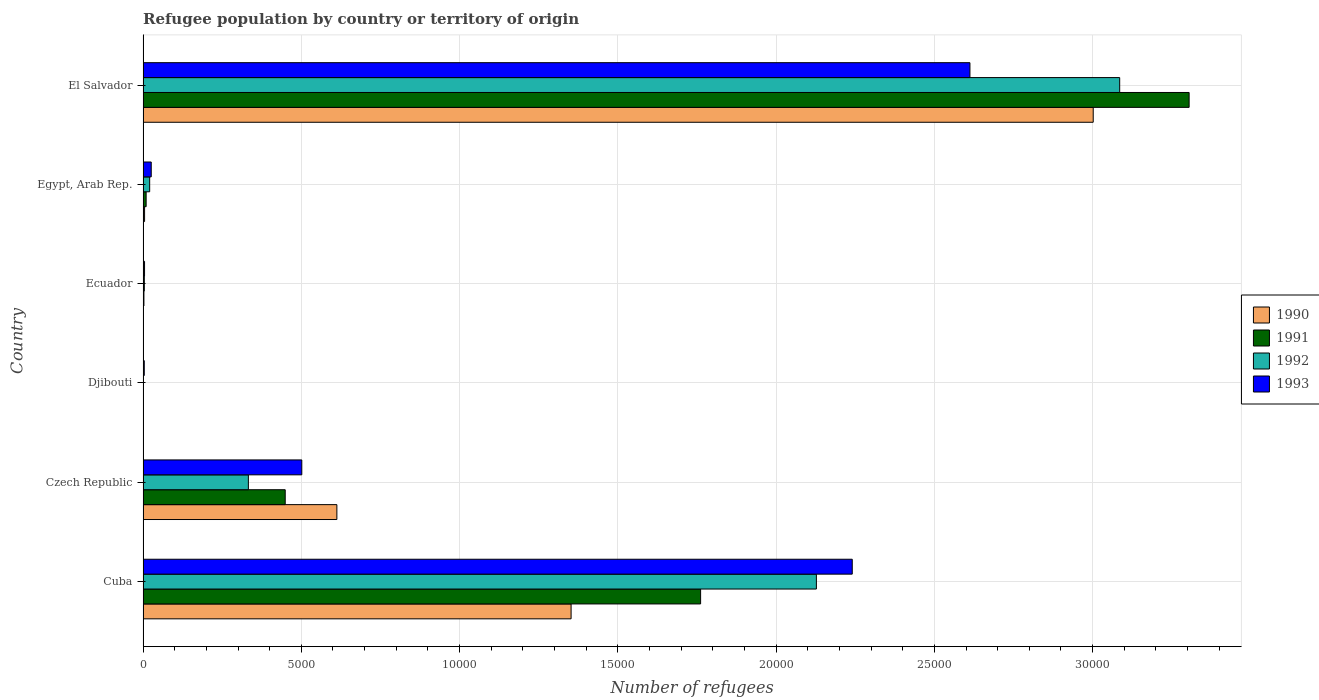How many different coloured bars are there?
Provide a short and direct response. 4. How many groups of bars are there?
Offer a terse response. 6. Are the number of bars per tick equal to the number of legend labels?
Your answer should be compact. Yes. Are the number of bars on each tick of the Y-axis equal?
Ensure brevity in your answer.  Yes. How many bars are there on the 3rd tick from the top?
Provide a succinct answer. 4. How many bars are there on the 5th tick from the bottom?
Your answer should be compact. 4. What is the label of the 4th group of bars from the top?
Your answer should be very brief. Djibouti. What is the number of refugees in 1993 in Czech Republic?
Provide a succinct answer. 5015. Across all countries, what is the maximum number of refugees in 1993?
Make the answer very short. 2.61e+04. Across all countries, what is the minimum number of refugees in 1992?
Offer a terse response. 11. In which country was the number of refugees in 1993 maximum?
Give a very brief answer. El Salvador. In which country was the number of refugees in 1993 minimum?
Provide a succinct answer. Djibouti. What is the total number of refugees in 1992 in the graph?
Your answer should be very brief. 5.57e+04. What is the difference between the number of refugees in 1990 in Cuba and that in Ecuador?
Give a very brief answer. 1.35e+04. What is the difference between the number of refugees in 1992 in El Salvador and the number of refugees in 1991 in Ecuador?
Offer a very short reply. 3.08e+04. What is the average number of refugees in 1991 per country?
Provide a succinct answer. 9214.83. What is the difference between the number of refugees in 1992 and number of refugees in 1993 in Ecuador?
Provide a succinct answer. -7. In how many countries, is the number of refugees in 1992 greater than 10000 ?
Offer a very short reply. 2. What is the ratio of the number of refugees in 1992 in Czech Republic to that in Djibouti?
Offer a terse response. 302.45. Is the number of refugees in 1991 in Djibouti less than that in El Salvador?
Ensure brevity in your answer.  Yes. Is the difference between the number of refugees in 1992 in Djibouti and Ecuador greater than the difference between the number of refugees in 1993 in Djibouti and Ecuador?
Offer a terse response. No. What is the difference between the highest and the second highest number of refugees in 1990?
Your answer should be compact. 1.65e+04. What is the difference between the highest and the lowest number of refugees in 1991?
Provide a short and direct response. 3.30e+04. Is the sum of the number of refugees in 1991 in Cuba and El Salvador greater than the maximum number of refugees in 1990 across all countries?
Your answer should be compact. Yes. What does the 1st bar from the bottom in Djibouti represents?
Offer a very short reply. 1990. Is it the case that in every country, the sum of the number of refugees in 1993 and number of refugees in 1990 is greater than the number of refugees in 1992?
Give a very brief answer. Yes. How many bars are there?
Offer a terse response. 24. Does the graph contain any zero values?
Provide a succinct answer. No. How many legend labels are there?
Your answer should be very brief. 4. How are the legend labels stacked?
Provide a succinct answer. Vertical. What is the title of the graph?
Provide a succinct answer. Refugee population by country or territory of origin. What is the label or title of the X-axis?
Your answer should be very brief. Number of refugees. What is the Number of refugees in 1990 in Cuba?
Offer a very short reply. 1.35e+04. What is the Number of refugees in 1991 in Cuba?
Make the answer very short. 1.76e+04. What is the Number of refugees of 1992 in Cuba?
Provide a short and direct response. 2.13e+04. What is the Number of refugees in 1993 in Cuba?
Your answer should be very brief. 2.24e+04. What is the Number of refugees of 1990 in Czech Republic?
Provide a succinct answer. 6123. What is the Number of refugees in 1991 in Czech Republic?
Provide a short and direct response. 4491. What is the Number of refugees in 1992 in Czech Republic?
Keep it short and to the point. 3327. What is the Number of refugees of 1993 in Czech Republic?
Keep it short and to the point. 5015. What is the Number of refugees of 1992 in Djibouti?
Your response must be concise. 11. What is the Number of refugees in 1990 in Ecuador?
Provide a short and direct response. 3. What is the Number of refugees of 1992 in Ecuador?
Ensure brevity in your answer.  40. What is the Number of refugees in 1990 in Egypt, Arab Rep.?
Your response must be concise. 48. What is the Number of refugees in 1991 in Egypt, Arab Rep.?
Your answer should be very brief. 97. What is the Number of refugees of 1992 in Egypt, Arab Rep.?
Offer a very short reply. 209. What is the Number of refugees in 1993 in Egypt, Arab Rep.?
Keep it short and to the point. 258. What is the Number of refugees of 1990 in El Salvador?
Ensure brevity in your answer.  3.00e+04. What is the Number of refugees in 1991 in El Salvador?
Provide a short and direct response. 3.30e+04. What is the Number of refugees of 1992 in El Salvador?
Provide a short and direct response. 3.09e+04. What is the Number of refugees of 1993 in El Salvador?
Keep it short and to the point. 2.61e+04. Across all countries, what is the maximum Number of refugees in 1990?
Your response must be concise. 3.00e+04. Across all countries, what is the maximum Number of refugees of 1991?
Ensure brevity in your answer.  3.30e+04. Across all countries, what is the maximum Number of refugees in 1992?
Make the answer very short. 3.09e+04. Across all countries, what is the maximum Number of refugees of 1993?
Make the answer very short. 2.61e+04. Across all countries, what is the minimum Number of refugees in 1990?
Make the answer very short. 3. Across all countries, what is the minimum Number of refugees of 1992?
Offer a very short reply. 11. What is the total Number of refugees of 1990 in the graph?
Offer a terse response. 4.97e+04. What is the total Number of refugees of 1991 in the graph?
Keep it short and to the point. 5.53e+04. What is the total Number of refugees in 1992 in the graph?
Your answer should be very brief. 5.57e+04. What is the total Number of refugees of 1993 in the graph?
Offer a terse response. 5.39e+04. What is the difference between the Number of refugees in 1990 in Cuba and that in Czech Republic?
Provide a short and direct response. 7400. What is the difference between the Number of refugees of 1991 in Cuba and that in Czech Republic?
Your response must be concise. 1.31e+04. What is the difference between the Number of refugees in 1992 in Cuba and that in Czech Republic?
Offer a terse response. 1.79e+04. What is the difference between the Number of refugees in 1993 in Cuba and that in Czech Republic?
Your answer should be compact. 1.74e+04. What is the difference between the Number of refugees of 1990 in Cuba and that in Djibouti?
Make the answer very short. 1.35e+04. What is the difference between the Number of refugees in 1991 in Cuba and that in Djibouti?
Keep it short and to the point. 1.76e+04. What is the difference between the Number of refugees of 1992 in Cuba and that in Djibouti?
Offer a very short reply. 2.13e+04. What is the difference between the Number of refugees of 1993 in Cuba and that in Djibouti?
Your answer should be very brief. 2.24e+04. What is the difference between the Number of refugees of 1990 in Cuba and that in Ecuador?
Make the answer very short. 1.35e+04. What is the difference between the Number of refugees in 1991 in Cuba and that in Ecuador?
Your answer should be very brief. 1.76e+04. What is the difference between the Number of refugees in 1992 in Cuba and that in Ecuador?
Give a very brief answer. 2.12e+04. What is the difference between the Number of refugees of 1993 in Cuba and that in Ecuador?
Keep it short and to the point. 2.24e+04. What is the difference between the Number of refugees of 1990 in Cuba and that in Egypt, Arab Rep.?
Your answer should be very brief. 1.35e+04. What is the difference between the Number of refugees in 1991 in Cuba and that in Egypt, Arab Rep.?
Give a very brief answer. 1.75e+04. What is the difference between the Number of refugees of 1992 in Cuba and that in Egypt, Arab Rep.?
Make the answer very short. 2.11e+04. What is the difference between the Number of refugees in 1993 in Cuba and that in Egypt, Arab Rep.?
Provide a short and direct response. 2.21e+04. What is the difference between the Number of refugees in 1990 in Cuba and that in El Salvador?
Your response must be concise. -1.65e+04. What is the difference between the Number of refugees of 1991 in Cuba and that in El Salvador?
Provide a short and direct response. -1.54e+04. What is the difference between the Number of refugees of 1992 in Cuba and that in El Salvador?
Offer a terse response. -9582. What is the difference between the Number of refugees in 1993 in Cuba and that in El Salvador?
Offer a very short reply. -3718. What is the difference between the Number of refugees in 1990 in Czech Republic and that in Djibouti?
Your response must be concise. 6118. What is the difference between the Number of refugees of 1991 in Czech Republic and that in Djibouti?
Offer a very short reply. 4481. What is the difference between the Number of refugees of 1992 in Czech Republic and that in Djibouti?
Offer a very short reply. 3316. What is the difference between the Number of refugees of 1993 in Czech Republic and that in Djibouti?
Ensure brevity in your answer.  4977. What is the difference between the Number of refugees in 1990 in Czech Republic and that in Ecuador?
Offer a terse response. 6120. What is the difference between the Number of refugees of 1991 in Czech Republic and that in Ecuador?
Make the answer very short. 4464. What is the difference between the Number of refugees of 1992 in Czech Republic and that in Ecuador?
Your answer should be compact. 3287. What is the difference between the Number of refugees of 1993 in Czech Republic and that in Ecuador?
Give a very brief answer. 4968. What is the difference between the Number of refugees in 1990 in Czech Republic and that in Egypt, Arab Rep.?
Keep it short and to the point. 6075. What is the difference between the Number of refugees in 1991 in Czech Republic and that in Egypt, Arab Rep.?
Give a very brief answer. 4394. What is the difference between the Number of refugees of 1992 in Czech Republic and that in Egypt, Arab Rep.?
Give a very brief answer. 3118. What is the difference between the Number of refugees of 1993 in Czech Republic and that in Egypt, Arab Rep.?
Offer a terse response. 4757. What is the difference between the Number of refugees in 1990 in Czech Republic and that in El Salvador?
Your answer should be very brief. -2.39e+04. What is the difference between the Number of refugees in 1991 in Czech Republic and that in El Salvador?
Provide a succinct answer. -2.86e+04. What is the difference between the Number of refugees in 1992 in Czech Republic and that in El Salvador?
Your answer should be compact. -2.75e+04. What is the difference between the Number of refugees in 1993 in Czech Republic and that in El Salvador?
Offer a very short reply. -2.11e+04. What is the difference between the Number of refugees in 1993 in Djibouti and that in Ecuador?
Your response must be concise. -9. What is the difference between the Number of refugees of 1990 in Djibouti and that in Egypt, Arab Rep.?
Provide a short and direct response. -43. What is the difference between the Number of refugees of 1991 in Djibouti and that in Egypt, Arab Rep.?
Provide a succinct answer. -87. What is the difference between the Number of refugees in 1992 in Djibouti and that in Egypt, Arab Rep.?
Give a very brief answer. -198. What is the difference between the Number of refugees in 1993 in Djibouti and that in Egypt, Arab Rep.?
Offer a terse response. -220. What is the difference between the Number of refugees in 1990 in Djibouti and that in El Salvador?
Keep it short and to the point. -3.00e+04. What is the difference between the Number of refugees of 1991 in Djibouti and that in El Salvador?
Offer a very short reply. -3.30e+04. What is the difference between the Number of refugees in 1992 in Djibouti and that in El Salvador?
Ensure brevity in your answer.  -3.08e+04. What is the difference between the Number of refugees in 1993 in Djibouti and that in El Salvador?
Give a very brief answer. -2.61e+04. What is the difference between the Number of refugees of 1990 in Ecuador and that in Egypt, Arab Rep.?
Make the answer very short. -45. What is the difference between the Number of refugees in 1991 in Ecuador and that in Egypt, Arab Rep.?
Keep it short and to the point. -70. What is the difference between the Number of refugees in 1992 in Ecuador and that in Egypt, Arab Rep.?
Your answer should be compact. -169. What is the difference between the Number of refugees of 1993 in Ecuador and that in Egypt, Arab Rep.?
Your answer should be compact. -211. What is the difference between the Number of refugees in 1990 in Ecuador and that in El Salvador?
Give a very brief answer. -3.00e+04. What is the difference between the Number of refugees of 1991 in Ecuador and that in El Salvador?
Provide a succinct answer. -3.30e+04. What is the difference between the Number of refugees in 1992 in Ecuador and that in El Salvador?
Provide a succinct answer. -3.08e+04. What is the difference between the Number of refugees in 1993 in Ecuador and that in El Salvador?
Keep it short and to the point. -2.61e+04. What is the difference between the Number of refugees of 1990 in Egypt, Arab Rep. and that in El Salvador?
Provide a short and direct response. -3.00e+04. What is the difference between the Number of refugees of 1991 in Egypt, Arab Rep. and that in El Salvador?
Offer a very short reply. -3.30e+04. What is the difference between the Number of refugees in 1992 in Egypt, Arab Rep. and that in El Salvador?
Make the answer very short. -3.06e+04. What is the difference between the Number of refugees in 1993 in Egypt, Arab Rep. and that in El Salvador?
Your answer should be compact. -2.59e+04. What is the difference between the Number of refugees of 1990 in Cuba and the Number of refugees of 1991 in Czech Republic?
Give a very brief answer. 9032. What is the difference between the Number of refugees of 1990 in Cuba and the Number of refugees of 1992 in Czech Republic?
Offer a very short reply. 1.02e+04. What is the difference between the Number of refugees in 1990 in Cuba and the Number of refugees in 1993 in Czech Republic?
Make the answer very short. 8508. What is the difference between the Number of refugees of 1991 in Cuba and the Number of refugees of 1992 in Czech Republic?
Offer a terse response. 1.43e+04. What is the difference between the Number of refugees of 1991 in Cuba and the Number of refugees of 1993 in Czech Republic?
Your response must be concise. 1.26e+04. What is the difference between the Number of refugees of 1992 in Cuba and the Number of refugees of 1993 in Czech Republic?
Your answer should be very brief. 1.63e+04. What is the difference between the Number of refugees of 1990 in Cuba and the Number of refugees of 1991 in Djibouti?
Your answer should be compact. 1.35e+04. What is the difference between the Number of refugees of 1990 in Cuba and the Number of refugees of 1992 in Djibouti?
Your answer should be very brief. 1.35e+04. What is the difference between the Number of refugees in 1990 in Cuba and the Number of refugees in 1993 in Djibouti?
Your answer should be compact. 1.35e+04. What is the difference between the Number of refugees in 1991 in Cuba and the Number of refugees in 1992 in Djibouti?
Make the answer very short. 1.76e+04. What is the difference between the Number of refugees in 1991 in Cuba and the Number of refugees in 1993 in Djibouti?
Offer a terse response. 1.76e+04. What is the difference between the Number of refugees in 1992 in Cuba and the Number of refugees in 1993 in Djibouti?
Give a very brief answer. 2.12e+04. What is the difference between the Number of refugees in 1990 in Cuba and the Number of refugees in 1991 in Ecuador?
Provide a succinct answer. 1.35e+04. What is the difference between the Number of refugees in 1990 in Cuba and the Number of refugees in 1992 in Ecuador?
Your answer should be compact. 1.35e+04. What is the difference between the Number of refugees of 1990 in Cuba and the Number of refugees of 1993 in Ecuador?
Provide a succinct answer. 1.35e+04. What is the difference between the Number of refugees of 1991 in Cuba and the Number of refugees of 1992 in Ecuador?
Make the answer very short. 1.76e+04. What is the difference between the Number of refugees in 1991 in Cuba and the Number of refugees in 1993 in Ecuador?
Your answer should be compact. 1.76e+04. What is the difference between the Number of refugees of 1992 in Cuba and the Number of refugees of 1993 in Ecuador?
Your response must be concise. 2.12e+04. What is the difference between the Number of refugees in 1990 in Cuba and the Number of refugees in 1991 in Egypt, Arab Rep.?
Provide a succinct answer. 1.34e+04. What is the difference between the Number of refugees of 1990 in Cuba and the Number of refugees of 1992 in Egypt, Arab Rep.?
Provide a succinct answer. 1.33e+04. What is the difference between the Number of refugees in 1990 in Cuba and the Number of refugees in 1993 in Egypt, Arab Rep.?
Your answer should be compact. 1.33e+04. What is the difference between the Number of refugees in 1991 in Cuba and the Number of refugees in 1992 in Egypt, Arab Rep.?
Ensure brevity in your answer.  1.74e+04. What is the difference between the Number of refugees in 1991 in Cuba and the Number of refugees in 1993 in Egypt, Arab Rep.?
Keep it short and to the point. 1.74e+04. What is the difference between the Number of refugees of 1992 in Cuba and the Number of refugees of 1993 in Egypt, Arab Rep.?
Keep it short and to the point. 2.10e+04. What is the difference between the Number of refugees of 1990 in Cuba and the Number of refugees of 1991 in El Salvador?
Your response must be concise. -1.95e+04. What is the difference between the Number of refugees of 1990 in Cuba and the Number of refugees of 1992 in El Salvador?
Keep it short and to the point. -1.73e+04. What is the difference between the Number of refugees in 1990 in Cuba and the Number of refugees in 1993 in El Salvador?
Offer a very short reply. -1.26e+04. What is the difference between the Number of refugees of 1991 in Cuba and the Number of refugees of 1992 in El Salvador?
Ensure brevity in your answer.  -1.32e+04. What is the difference between the Number of refugees in 1991 in Cuba and the Number of refugees in 1993 in El Salvador?
Ensure brevity in your answer.  -8509. What is the difference between the Number of refugees of 1992 in Cuba and the Number of refugees of 1993 in El Salvador?
Offer a very short reply. -4851. What is the difference between the Number of refugees of 1990 in Czech Republic and the Number of refugees of 1991 in Djibouti?
Your answer should be compact. 6113. What is the difference between the Number of refugees of 1990 in Czech Republic and the Number of refugees of 1992 in Djibouti?
Make the answer very short. 6112. What is the difference between the Number of refugees of 1990 in Czech Republic and the Number of refugees of 1993 in Djibouti?
Your answer should be very brief. 6085. What is the difference between the Number of refugees in 1991 in Czech Republic and the Number of refugees in 1992 in Djibouti?
Make the answer very short. 4480. What is the difference between the Number of refugees in 1991 in Czech Republic and the Number of refugees in 1993 in Djibouti?
Make the answer very short. 4453. What is the difference between the Number of refugees in 1992 in Czech Republic and the Number of refugees in 1993 in Djibouti?
Give a very brief answer. 3289. What is the difference between the Number of refugees in 1990 in Czech Republic and the Number of refugees in 1991 in Ecuador?
Provide a short and direct response. 6096. What is the difference between the Number of refugees in 1990 in Czech Republic and the Number of refugees in 1992 in Ecuador?
Make the answer very short. 6083. What is the difference between the Number of refugees in 1990 in Czech Republic and the Number of refugees in 1993 in Ecuador?
Provide a short and direct response. 6076. What is the difference between the Number of refugees of 1991 in Czech Republic and the Number of refugees of 1992 in Ecuador?
Your answer should be compact. 4451. What is the difference between the Number of refugees in 1991 in Czech Republic and the Number of refugees in 1993 in Ecuador?
Offer a very short reply. 4444. What is the difference between the Number of refugees of 1992 in Czech Republic and the Number of refugees of 1993 in Ecuador?
Offer a terse response. 3280. What is the difference between the Number of refugees of 1990 in Czech Republic and the Number of refugees of 1991 in Egypt, Arab Rep.?
Ensure brevity in your answer.  6026. What is the difference between the Number of refugees of 1990 in Czech Republic and the Number of refugees of 1992 in Egypt, Arab Rep.?
Your response must be concise. 5914. What is the difference between the Number of refugees of 1990 in Czech Republic and the Number of refugees of 1993 in Egypt, Arab Rep.?
Your answer should be very brief. 5865. What is the difference between the Number of refugees of 1991 in Czech Republic and the Number of refugees of 1992 in Egypt, Arab Rep.?
Your answer should be very brief. 4282. What is the difference between the Number of refugees of 1991 in Czech Republic and the Number of refugees of 1993 in Egypt, Arab Rep.?
Ensure brevity in your answer.  4233. What is the difference between the Number of refugees of 1992 in Czech Republic and the Number of refugees of 1993 in Egypt, Arab Rep.?
Offer a very short reply. 3069. What is the difference between the Number of refugees in 1990 in Czech Republic and the Number of refugees in 1991 in El Salvador?
Make the answer very short. -2.69e+04. What is the difference between the Number of refugees of 1990 in Czech Republic and the Number of refugees of 1992 in El Salvador?
Your response must be concise. -2.47e+04. What is the difference between the Number of refugees in 1990 in Czech Republic and the Number of refugees in 1993 in El Salvador?
Keep it short and to the point. -2.00e+04. What is the difference between the Number of refugees in 1991 in Czech Republic and the Number of refugees in 1992 in El Salvador?
Your response must be concise. -2.64e+04. What is the difference between the Number of refugees of 1991 in Czech Republic and the Number of refugees of 1993 in El Salvador?
Your answer should be compact. -2.16e+04. What is the difference between the Number of refugees in 1992 in Czech Republic and the Number of refugees in 1993 in El Salvador?
Provide a short and direct response. -2.28e+04. What is the difference between the Number of refugees of 1990 in Djibouti and the Number of refugees of 1992 in Ecuador?
Offer a very short reply. -35. What is the difference between the Number of refugees in 1990 in Djibouti and the Number of refugees in 1993 in Ecuador?
Provide a short and direct response. -42. What is the difference between the Number of refugees in 1991 in Djibouti and the Number of refugees in 1993 in Ecuador?
Provide a short and direct response. -37. What is the difference between the Number of refugees of 1992 in Djibouti and the Number of refugees of 1993 in Ecuador?
Ensure brevity in your answer.  -36. What is the difference between the Number of refugees in 1990 in Djibouti and the Number of refugees in 1991 in Egypt, Arab Rep.?
Provide a succinct answer. -92. What is the difference between the Number of refugees in 1990 in Djibouti and the Number of refugees in 1992 in Egypt, Arab Rep.?
Your answer should be compact. -204. What is the difference between the Number of refugees in 1990 in Djibouti and the Number of refugees in 1993 in Egypt, Arab Rep.?
Offer a terse response. -253. What is the difference between the Number of refugees of 1991 in Djibouti and the Number of refugees of 1992 in Egypt, Arab Rep.?
Provide a short and direct response. -199. What is the difference between the Number of refugees of 1991 in Djibouti and the Number of refugees of 1993 in Egypt, Arab Rep.?
Provide a short and direct response. -248. What is the difference between the Number of refugees in 1992 in Djibouti and the Number of refugees in 1993 in Egypt, Arab Rep.?
Your answer should be compact. -247. What is the difference between the Number of refugees in 1990 in Djibouti and the Number of refugees in 1991 in El Salvador?
Provide a succinct answer. -3.30e+04. What is the difference between the Number of refugees in 1990 in Djibouti and the Number of refugees in 1992 in El Salvador?
Your answer should be very brief. -3.08e+04. What is the difference between the Number of refugees of 1990 in Djibouti and the Number of refugees of 1993 in El Salvador?
Ensure brevity in your answer.  -2.61e+04. What is the difference between the Number of refugees in 1991 in Djibouti and the Number of refugees in 1992 in El Salvador?
Give a very brief answer. -3.08e+04. What is the difference between the Number of refugees of 1991 in Djibouti and the Number of refugees of 1993 in El Salvador?
Ensure brevity in your answer.  -2.61e+04. What is the difference between the Number of refugees in 1992 in Djibouti and the Number of refugees in 1993 in El Salvador?
Give a very brief answer. -2.61e+04. What is the difference between the Number of refugees in 1990 in Ecuador and the Number of refugees in 1991 in Egypt, Arab Rep.?
Your answer should be compact. -94. What is the difference between the Number of refugees of 1990 in Ecuador and the Number of refugees of 1992 in Egypt, Arab Rep.?
Offer a very short reply. -206. What is the difference between the Number of refugees of 1990 in Ecuador and the Number of refugees of 1993 in Egypt, Arab Rep.?
Keep it short and to the point. -255. What is the difference between the Number of refugees of 1991 in Ecuador and the Number of refugees of 1992 in Egypt, Arab Rep.?
Your answer should be compact. -182. What is the difference between the Number of refugees in 1991 in Ecuador and the Number of refugees in 1993 in Egypt, Arab Rep.?
Make the answer very short. -231. What is the difference between the Number of refugees in 1992 in Ecuador and the Number of refugees in 1993 in Egypt, Arab Rep.?
Offer a terse response. -218. What is the difference between the Number of refugees of 1990 in Ecuador and the Number of refugees of 1991 in El Salvador?
Your answer should be very brief. -3.30e+04. What is the difference between the Number of refugees of 1990 in Ecuador and the Number of refugees of 1992 in El Salvador?
Provide a succinct answer. -3.09e+04. What is the difference between the Number of refugees of 1990 in Ecuador and the Number of refugees of 1993 in El Salvador?
Your answer should be very brief. -2.61e+04. What is the difference between the Number of refugees in 1991 in Ecuador and the Number of refugees in 1992 in El Salvador?
Your response must be concise. -3.08e+04. What is the difference between the Number of refugees in 1991 in Ecuador and the Number of refugees in 1993 in El Salvador?
Offer a very short reply. -2.61e+04. What is the difference between the Number of refugees in 1992 in Ecuador and the Number of refugees in 1993 in El Salvador?
Your response must be concise. -2.61e+04. What is the difference between the Number of refugees in 1990 in Egypt, Arab Rep. and the Number of refugees in 1991 in El Salvador?
Ensure brevity in your answer.  -3.30e+04. What is the difference between the Number of refugees in 1990 in Egypt, Arab Rep. and the Number of refugees in 1992 in El Salvador?
Your answer should be very brief. -3.08e+04. What is the difference between the Number of refugees in 1990 in Egypt, Arab Rep. and the Number of refugees in 1993 in El Salvador?
Offer a very short reply. -2.61e+04. What is the difference between the Number of refugees in 1991 in Egypt, Arab Rep. and the Number of refugees in 1992 in El Salvador?
Provide a short and direct response. -3.08e+04. What is the difference between the Number of refugees of 1991 in Egypt, Arab Rep. and the Number of refugees of 1993 in El Salvador?
Keep it short and to the point. -2.60e+04. What is the difference between the Number of refugees in 1992 in Egypt, Arab Rep. and the Number of refugees in 1993 in El Salvador?
Your answer should be very brief. -2.59e+04. What is the average Number of refugees in 1990 per country?
Ensure brevity in your answer.  8286.83. What is the average Number of refugees of 1991 per country?
Offer a terse response. 9214.83. What is the average Number of refugees in 1992 per country?
Make the answer very short. 9285.83. What is the average Number of refugees of 1993 per country?
Your response must be concise. 8981.33. What is the difference between the Number of refugees of 1990 and Number of refugees of 1991 in Cuba?
Your answer should be compact. -4092. What is the difference between the Number of refugees of 1990 and Number of refugees of 1992 in Cuba?
Offer a terse response. -7750. What is the difference between the Number of refugees of 1990 and Number of refugees of 1993 in Cuba?
Your response must be concise. -8883. What is the difference between the Number of refugees of 1991 and Number of refugees of 1992 in Cuba?
Ensure brevity in your answer.  -3658. What is the difference between the Number of refugees in 1991 and Number of refugees in 1993 in Cuba?
Your response must be concise. -4791. What is the difference between the Number of refugees of 1992 and Number of refugees of 1993 in Cuba?
Make the answer very short. -1133. What is the difference between the Number of refugees in 1990 and Number of refugees in 1991 in Czech Republic?
Make the answer very short. 1632. What is the difference between the Number of refugees of 1990 and Number of refugees of 1992 in Czech Republic?
Keep it short and to the point. 2796. What is the difference between the Number of refugees of 1990 and Number of refugees of 1993 in Czech Republic?
Your response must be concise. 1108. What is the difference between the Number of refugees of 1991 and Number of refugees of 1992 in Czech Republic?
Keep it short and to the point. 1164. What is the difference between the Number of refugees in 1991 and Number of refugees in 1993 in Czech Republic?
Your response must be concise. -524. What is the difference between the Number of refugees of 1992 and Number of refugees of 1993 in Czech Republic?
Provide a succinct answer. -1688. What is the difference between the Number of refugees of 1990 and Number of refugees of 1991 in Djibouti?
Provide a short and direct response. -5. What is the difference between the Number of refugees of 1990 and Number of refugees of 1992 in Djibouti?
Provide a short and direct response. -6. What is the difference between the Number of refugees in 1990 and Number of refugees in 1993 in Djibouti?
Your answer should be compact. -33. What is the difference between the Number of refugees in 1992 and Number of refugees in 1993 in Djibouti?
Give a very brief answer. -27. What is the difference between the Number of refugees in 1990 and Number of refugees in 1992 in Ecuador?
Your answer should be compact. -37. What is the difference between the Number of refugees of 1990 and Number of refugees of 1993 in Ecuador?
Your response must be concise. -44. What is the difference between the Number of refugees in 1991 and Number of refugees in 1992 in Ecuador?
Your answer should be very brief. -13. What is the difference between the Number of refugees of 1990 and Number of refugees of 1991 in Egypt, Arab Rep.?
Your response must be concise. -49. What is the difference between the Number of refugees of 1990 and Number of refugees of 1992 in Egypt, Arab Rep.?
Ensure brevity in your answer.  -161. What is the difference between the Number of refugees of 1990 and Number of refugees of 1993 in Egypt, Arab Rep.?
Your answer should be compact. -210. What is the difference between the Number of refugees in 1991 and Number of refugees in 1992 in Egypt, Arab Rep.?
Make the answer very short. -112. What is the difference between the Number of refugees of 1991 and Number of refugees of 1993 in Egypt, Arab Rep.?
Give a very brief answer. -161. What is the difference between the Number of refugees in 1992 and Number of refugees in 1993 in Egypt, Arab Rep.?
Keep it short and to the point. -49. What is the difference between the Number of refugees in 1990 and Number of refugees in 1991 in El Salvador?
Make the answer very short. -3030. What is the difference between the Number of refugees in 1990 and Number of refugees in 1992 in El Salvador?
Your response must be concise. -836. What is the difference between the Number of refugees in 1990 and Number of refugees in 1993 in El Salvador?
Your answer should be very brief. 3895. What is the difference between the Number of refugees in 1991 and Number of refugees in 1992 in El Salvador?
Give a very brief answer. 2194. What is the difference between the Number of refugees of 1991 and Number of refugees of 1993 in El Salvador?
Give a very brief answer. 6925. What is the difference between the Number of refugees of 1992 and Number of refugees of 1993 in El Salvador?
Ensure brevity in your answer.  4731. What is the ratio of the Number of refugees in 1990 in Cuba to that in Czech Republic?
Your answer should be very brief. 2.21. What is the ratio of the Number of refugees in 1991 in Cuba to that in Czech Republic?
Keep it short and to the point. 3.92. What is the ratio of the Number of refugees of 1992 in Cuba to that in Czech Republic?
Offer a very short reply. 6.39. What is the ratio of the Number of refugees in 1993 in Cuba to that in Czech Republic?
Provide a short and direct response. 4.47. What is the ratio of the Number of refugees in 1990 in Cuba to that in Djibouti?
Your answer should be very brief. 2704.6. What is the ratio of the Number of refugees of 1991 in Cuba to that in Djibouti?
Your response must be concise. 1761.5. What is the ratio of the Number of refugees of 1992 in Cuba to that in Djibouti?
Offer a very short reply. 1933.91. What is the ratio of the Number of refugees of 1993 in Cuba to that in Djibouti?
Offer a terse response. 589.63. What is the ratio of the Number of refugees of 1990 in Cuba to that in Ecuador?
Offer a terse response. 4507.67. What is the ratio of the Number of refugees of 1991 in Cuba to that in Ecuador?
Give a very brief answer. 652.41. What is the ratio of the Number of refugees in 1992 in Cuba to that in Ecuador?
Provide a succinct answer. 531.83. What is the ratio of the Number of refugees of 1993 in Cuba to that in Ecuador?
Ensure brevity in your answer.  476.72. What is the ratio of the Number of refugees of 1990 in Cuba to that in Egypt, Arab Rep.?
Offer a very short reply. 281.73. What is the ratio of the Number of refugees in 1991 in Cuba to that in Egypt, Arab Rep.?
Keep it short and to the point. 181.6. What is the ratio of the Number of refugees in 1992 in Cuba to that in Egypt, Arab Rep.?
Offer a very short reply. 101.78. What is the ratio of the Number of refugees of 1993 in Cuba to that in Egypt, Arab Rep.?
Your answer should be very brief. 86.84. What is the ratio of the Number of refugees of 1990 in Cuba to that in El Salvador?
Ensure brevity in your answer.  0.45. What is the ratio of the Number of refugees in 1991 in Cuba to that in El Salvador?
Give a very brief answer. 0.53. What is the ratio of the Number of refugees of 1992 in Cuba to that in El Salvador?
Your answer should be compact. 0.69. What is the ratio of the Number of refugees in 1993 in Cuba to that in El Salvador?
Provide a short and direct response. 0.86. What is the ratio of the Number of refugees of 1990 in Czech Republic to that in Djibouti?
Your answer should be very brief. 1224.6. What is the ratio of the Number of refugees of 1991 in Czech Republic to that in Djibouti?
Offer a very short reply. 449.1. What is the ratio of the Number of refugees in 1992 in Czech Republic to that in Djibouti?
Offer a very short reply. 302.45. What is the ratio of the Number of refugees in 1993 in Czech Republic to that in Djibouti?
Give a very brief answer. 131.97. What is the ratio of the Number of refugees of 1990 in Czech Republic to that in Ecuador?
Offer a very short reply. 2041. What is the ratio of the Number of refugees in 1991 in Czech Republic to that in Ecuador?
Provide a succinct answer. 166.33. What is the ratio of the Number of refugees in 1992 in Czech Republic to that in Ecuador?
Keep it short and to the point. 83.17. What is the ratio of the Number of refugees of 1993 in Czech Republic to that in Ecuador?
Provide a succinct answer. 106.7. What is the ratio of the Number of refugees in 1990 in Czech Republic to that in Egypt, Arab Rep.?
Provide a short and direct response. 127.56. What is the ratio of the Number of refugees in 1991 in Czech Republic to that in Egypt, Arab Rep.?
Offer a very short reply. 46.3. What is the ratio of the Number of refugees of 1992 in Czech Republic to that in Egypt, Arab Rep.?
Keep it short and to the point. 15.92. What is the ratio of the Number of refugees of 1993 in Czech Republic to that in Egypt, Arab Rep.?
Your answer should be very brief. 19.44. What is the ratio of the Number of refugees in 1990 in Czech Republic to that in El Salvador?
Keep it short and to the point. 0.2. What is the ratio of the Number of refugees in 1991 in Czech Republic to that in El Salvador?
Offer a very short reply. 0.14. What is the ratio of the Number of refugees of 1992 in Czech Republic to that in El Salvador?
Make the answer very short. 0.11. What is the ratio of the Number of refugees in 1993 in Czech Republic to that in El Salvador?
Give a very brief answer. 0.19. What is the ratio of the Number of refugees in 1991 in Djibouti to that in Ecuador?
Make the answer very short. 0.37. What is the ratio of the Number of refugees of 1992 in Djibouti to that in Ecuador?
Provide a succinct answer. 0.28. What is the ratio of the Number of refugees in 1993 in Djibouti to that in Ecuador?
Your answer should be compact. 0.81. What is the ratio of the Number of refugees of 1990 in Djibouti to that in Egypt, Arab Rep.?
Ensure brevity in your answer.  0.1. What is the ratio of the Number of refugees of 1991 in Djibouti to that in Egypt, Arab Rep.?
Your response must be concise. 0.1. What is the ratio of the Number of refugees of 1992 in Djibouti to that in Egypt, Arab Rep.?
Provide a short and direct response. 0.05. What is the ratio of the Number of refugees in 1993 in Djibouti to that in Egypt, Arab Rep.?
Provide a short and direct response. 0.15. What is the ratio of the Number of refugees of 1990 in Djibouti to that in El Salvador?
Make the answer very short. 0. What is the ratio of the Number of refugees of 1991 in Djibouti to that in El Salvador?
Give a very brief answer. 0. What is the ratio of the Number of refugees of 1992 in Djibouti to that in El Salvador?
Ensure brevity in your answer.  0. What is the ratio of the Number of refugees of 1993 in Djibouti to that in El Salvador?
Keep it short and to the point. 0. What is the ratio of the Number of refugees of 1990 in Ecuador to that in Egypt, Arab Rep.?
Keep it short and to the point. 0.06. What is the ratio of the Number of refugees of 1991 in Ecuador to that in Egypt, Arab Rep.?
Your answer should be compact. 0.28. What is the ratio of the Number of refugees of 1992 in Ecuador to that in Egypt, Arab Rep.?
Your answer should be compact. 0.19. What is the ratio of the Number of refugees of 1993 in Ecuador to that in Egypt, Arab Rep.?
Your answer should be compact. 0.18. What is the ratio of the Number of refugees in 1991 in Ecuador to that in El Salvador?
Provide a short and direct response. 0. What is the ratio of the Number of refugees in 1992 in Ecuador to that in El Salvador?
Your answer should be very brief. 0. What is the ratio of the Number of refugees of 1993 in Ecuador to that in El Salvador?
Provide a succinct answer. 0. What is the ratio of the Number of refugees of 1990 in Egypt, Arab Rep. to that in El Salvador?
Provide a succinct answer. 0. What is the ratio of the Number of refugees of 1991 in Egypt, Arab Rep. to that in El Salvador?
Offer a terse response. 0. What is the ratio of the Number of refugees in 1992 in Egypt, Arab Rep. to that in El Salvador?
Provide a succinct answer. 0.01. What is the ratio of the Number of refugees of 1993 in Egypt, Arab Rep. to that in El Salvador?
Your answer should be very brief. 0.01. What is the difference between the highest and the second highest Number of refugees in 1990?
Your response must be concise. 1.65e+04. What is the difference between the highest and the second highest Number of refugees of 1991?
Offer a terse response. 1.54e+04. What is the difference between the highest and the second highest Number of refugees of 1992?
Your response must be concise. 9582. What is the difference between the highest and the second highest Number of refugees of 1993?
Provide a short and direct response. 3718. What is the difference between the highest and the lowest Number of refugees of 1990?
Offer a very short reply. 3.00e+04. What is the difference between the highest and the lowest Number of refugees in 1991?
Your response must be concise. 3.30e+04. What is the difference between the highest and the lowest Number of refugees of 1992?
Offer a terse response. 3.08e+04. What is the difference between the highest and the lowest Number of refugees in 1993?
Provide a short and direct response. 2.61e+04. 